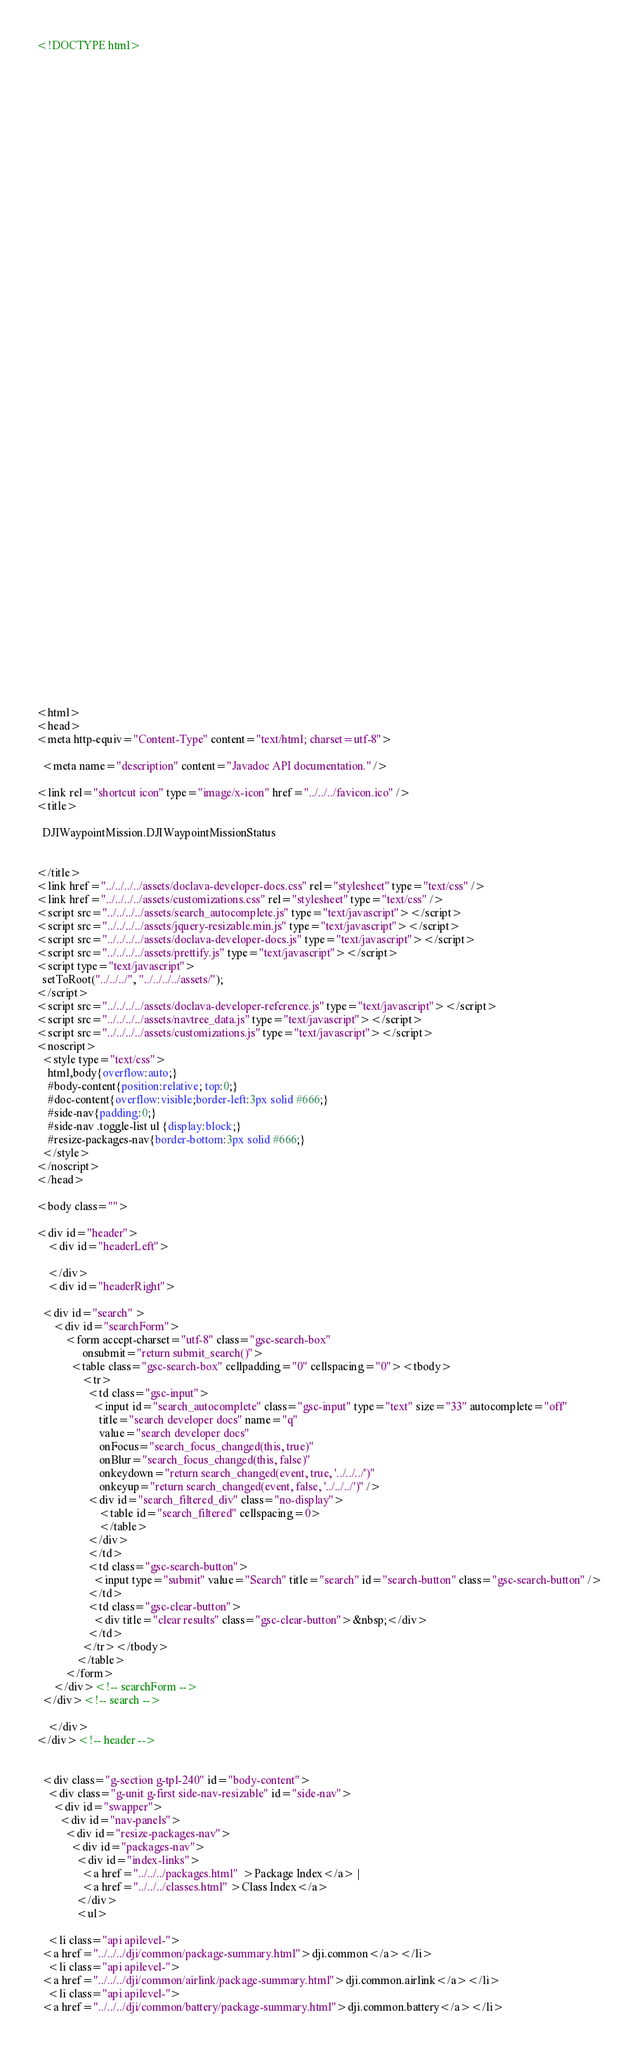Convert code to text. <code><loc_0><loc_0><loc_500><loc_500><_HTML_><!DOCTYPE html>

















































<html>
<head>
<meta http-equiv="Content-Type" content="text/html; charset=utf-8">

  <meta name="description" content="Javadoc API documentation." />

<link rel="shortcut icon" type="image/x-icon" href="../../../favicon.ico" />
<title>

  DJIWaypointMission.DJIWaypointMissionStatus


</title>
<link href="../../../../assets/doclava-developer-docs.css" rel="stylesheet" type="text/css" />
<link href="../../../../assets/customizations.css" rel="stylesheet" type="text/css" />
<script src="../../../../assets/search_autocomplete.js" type="text/javascript"></script>
<script src="../../../../assets/jquery-resizable.min.js" type="text/javascript"></script>
<script src="../../../../assets/doclava-developer-docs.js" type="text/javascript"></script>
<script src="../../../../assets/prettify.js" type="text/javascript"></script>
<script type="text/javascript">
  setToRoot("../../../", "../../../../assets/");
</script>
<script src="../../../../assets/doclava-developer-reference.js" type="text/javascript"></script>
<script src="../../../../assets/navtree_data.js" type="text/javascript"></script>
<script src="../../../../assets/customizations.js" type="text/javascript"></script>
<noscript>
  <style type="text/css">
    html,body{overflow:auto;}
    #body-content{position:relative; top:0;}
    #doc-content{overflow:visible;border-left:3px solid #666;}
    #side-nav{padding:0;}
    #side-nav .toggle-list ul {display:block;}
    #resize-packages-nav{border-bottom:3px solid #666;}
  </style>
</noscript>
</head>

<body class="">

<div id="header">
    <div id="headerLeft">
    
    </div>
    <div id="headerRight">
      
  <div id="search" >
      <div id="searchForm">
          <form accept-charset="utf-8" class="gsc-search-box" 
                onsubmit="return submit_search()">
            <table class="gsc-search-box" cellpadding="0" cellspacing="0"><tbody>
                <tr>
                  <td class="gsc-input">
                    <input id="search_autocomplete" class="gsc-input" type="text" size="33" autocomplete="off"
                      title="search developer docs" name="q"
                      value="search developer docs"
                      onFocus="search_focus_changed(this, true)"
                      onBlur="search_focus_changed(this, false)"
                      onkeydown="return search_changed(event, true, '../../../')"
                      onkeyup="return search_changed(event, false, '../../../')" />
                  <div id="search_filtered_div" class="no-display">
                      <table id="search_filtered" cellspacing=0>
                      </table>
                  </div>
                  </td>
                  <td class="gsc-search-button">
                    <input type="submit" value="Search" title="search" id="search-button" class="gsc-search-button" />
                  </td>
                  <td class="gsc-clear-button">
                    <div title="clear results" class="gsc-clear-button">&nbsp;</div>
                  </td>
                </tr></tbody>
              </table>
          </form>
      </div><!-- searchForm -->
  </div><!-- search -->
      
    </div>
</div><!-- header -->


  <div class="g-section g-tpl-240" id="body-content">
    <div class="g-unit g-first side-nav-resizable" id="side-nav">
      <div id="swapper">
        <div id="nav-panels">
          <div id="resize-packages-nav">
            <div id="packages-nav">
              <div id="index-links">
                <a href="../../../packages.html"  >Package Index</a> | 
                <a href="../../../classes.html" >Class Index</a>
              </div>
              <ul>
                
    <li class="api apilevel-">
  <a href="../../../dji/common/package-summary.html">dji.common</a></li>
    <li class="api apilevel-">
  <a href="../../../dji/common/airlink/package-summary.html">dji.common.airlink</a></li>
    <li class="api apilevel-">
  <a href="../../../dji/common/battery/package-summary.html">dji.common.battery</a></li></code> 